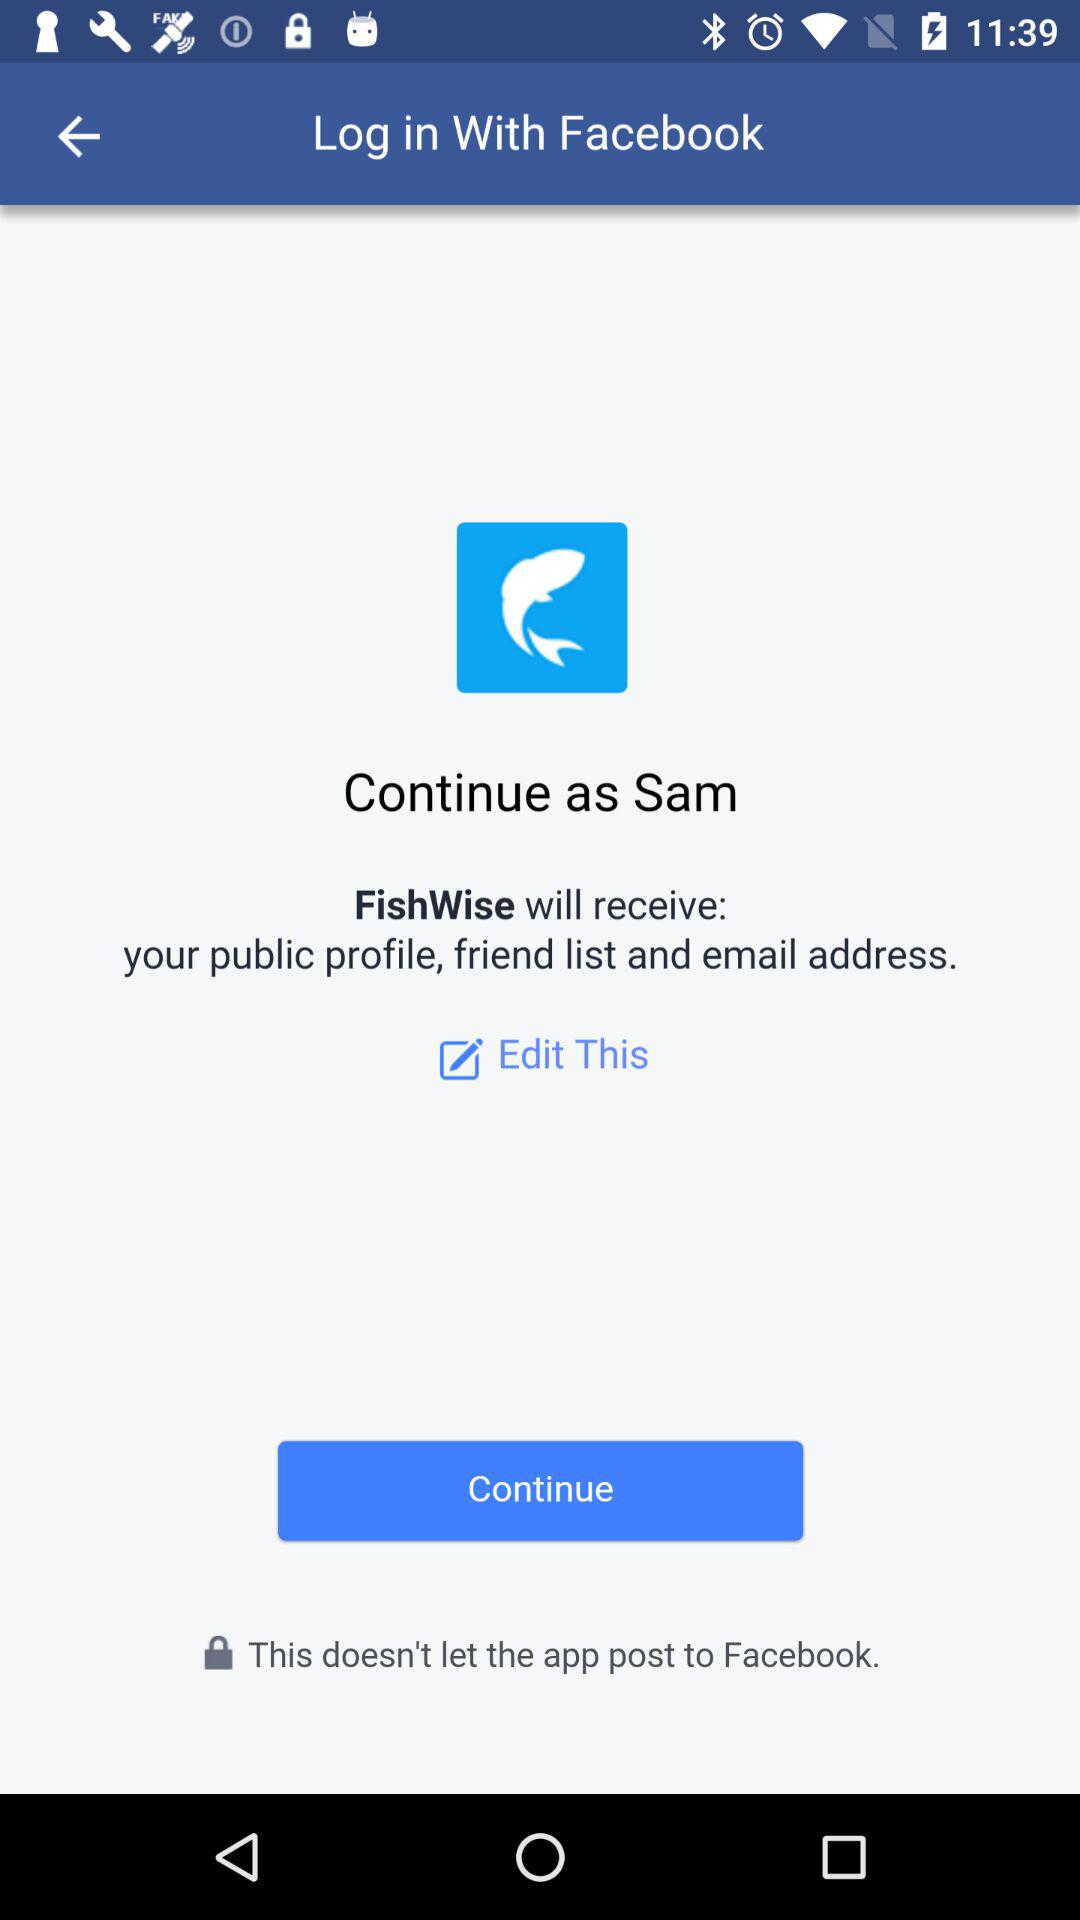What is the name of the user? The name of the user is Sam. 